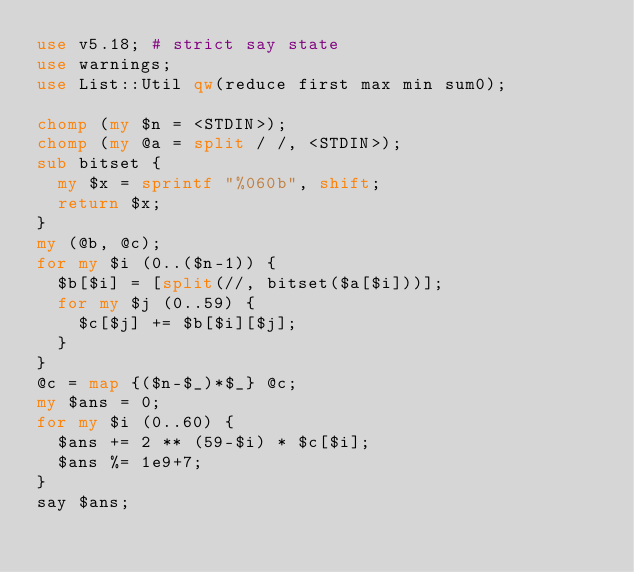Convert code to text. <code><loc_0><loc_0><loc_500><loc_500><_Perl_>use v5.18; # strict say state
use warnings;
use List::Util qw(reduce first max min sum0);

chomp (my $n = <STDIN>);
chomp (my @a = split / /, <STDIN>);
sub bitset {
  my $x = sprintf "%060b", shift;
  return $x;
}
my (@b, @c);
for my $i (0..($n-1)) {
  $b[$i] = [split(//, bitset($a[$i]))];
  for my $j (0..59) {
    $c[$j] += $b[$i][$j];
  }
}
@c = map {($n-$_)*$_} @c;
my $ans = 0;
for my $i (0..60) {
  $ans += 2 ** (59-$i) * $c[$i];
  $ans %= 1e9+7;
}
say $ans;</code> 